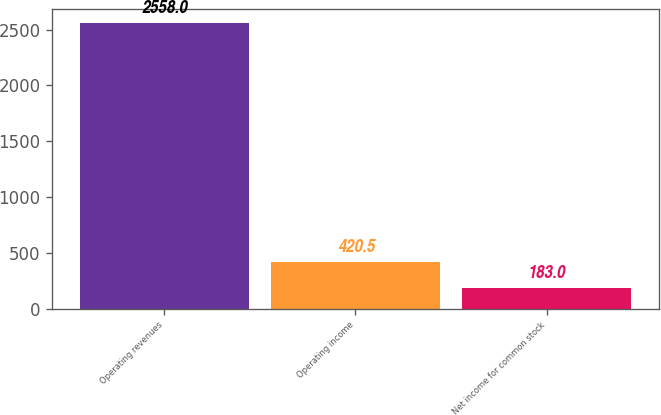Convert chart. <chart><loc_0><loc_0><loc_500><loc_500><bar_chart><fcel>Operating revenues<fcel>Operating income<fcel>Net income for common stock<nl><fcel>2558<fcel>420.5<fcel>183<nl></chart> 